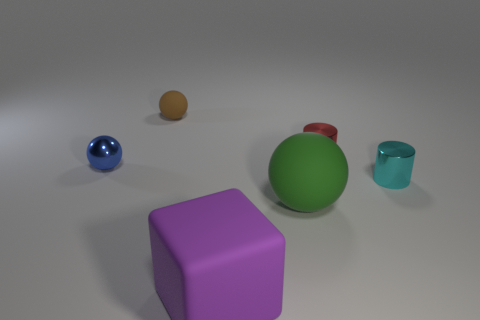Add 3 large spheres. How many objects exist? 9 Subtract all blocks. How many objects are left? 5 Subtract 1 blue spheres. How many objects are left? 5 Subtract all red metal things. Subtract all tiny cyan objects. How many objects are left? 4 Add 2 cubes. How many cubes are left? 3 Add 4 small cylinders. How many small cylinders exist? 6 